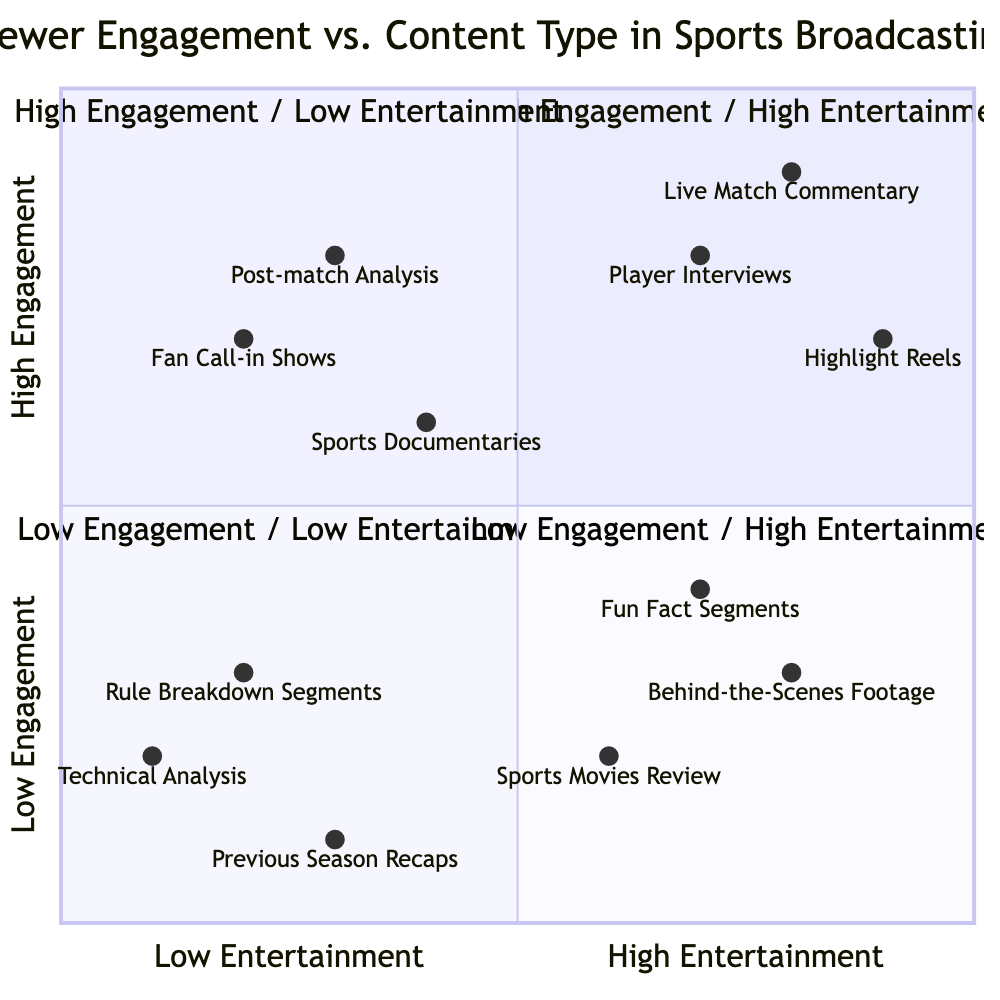What content type is in the High Engagement / High Entertainment quadrant? In the High Engagement / High Entertainment quadrant, the content types listed are Live Match Commentary, Player Interviews, and Highlight Reels.
Answer: Live Match Commentary How many content types are present in the Low Engagement / Low Entertainment quadrant? There are three content types listed in the Low Engagement / Low Entertainment quadrant: Rule Breakdown Segments, Technical Analysis, and Previous Season Recaps.
Answer: Three Which content type is the least entertaining according to the diagram? The content type with the least entertainment factor appears in the Low Engagement / Low Entertainment quadrant; it is Rule Breakdown Segments as it does not engage or entertain viewers significantly.
Answer: Rule Breakdown Segments What is the engagement level of Fun Fact Segments? Fun Fact Segments are positioned in the Low Engagement / High Entertainment quadrant, indicating that they have a low engagement level.
Answer: Low In which quadrant are Player Interviews located? Player Interviews are found in the High Engagement / High Entertainment quadrant, indicating they are both engaging and entertaining.
Answer: High Engagement / High Entertainment Which content type has the highest entertainment rating according to the diagram? Highlight Reels are among the highest in entertainment, falling in the High Engagement / High Entertainment quadrant and rating close to the top in entertainment.
Answer: Highlight Reels Which two quadrants involve high engagement? The two quadrants that involve high engagement are High Engagement / High Entertainment and High Engagement / Low Entertainment.
Answer: High Engagement / High Entertainment and High Engagement / Low Entertainment What is the example of the content type listed under Sports Documentaries? The example provided for Sports Documentaries is a documentary about the 1995 Ajax Team, showing it as a type of content that informs yet engages an audience.
Answer: Documentary on the 1995 Ajax Team What is the engagement level of Sports Movies Review? Sports Movies Review is in the Low Engagement / High Entertainment quadrant, meaning it has a low engagement level despite being entertaining.
Answer: Low 